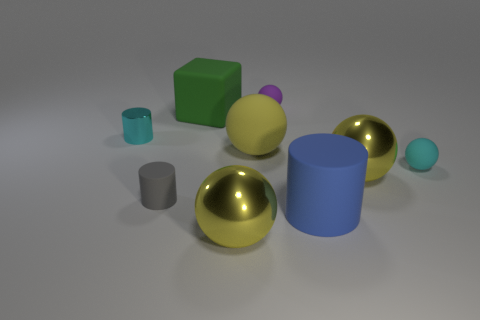There is a small shiny cylinder; does it have the same color as the small rubber sphere that is in front of the large green cube?
Your response must be concise. Yes. What number of other objects are there of the same material as the small cyan ball?
Your answer should be compact. 5. There is a tiny cyan thing that is made of the same material as the cube; what shape is it?
Give a very brief answer. Sphere. Is there any other thing that is the same color as the big rubber cube?
Ensure brevity in your answer.  No. What is the size of the rubber ball that is the same color as the shiny cylinder?
Give a very brief answer. Small. Are there more yellow things that are right of the tiny gray matte cylinder than small red metal balls?
Your answer should be compact. Yes. There is a blue rubber object; does it have the same shape as the gray rubber object in front of the small cyan cylinder?
Your response must be concise. Yes. What number of metal spheres are the same size as the blue matte object?
Provide a succinct answer. 2. There is a large yellow object to the right of the big yellow rubber object to the left of the small purple rubber ball; how many spheres are on the left side of it?
Your answer should be compact. 3. Are there the same number of gray objects in front of the tiny metal thing and big objects to the right of the tiny cyan rubber thing?
Provide a succinct answer. No. 